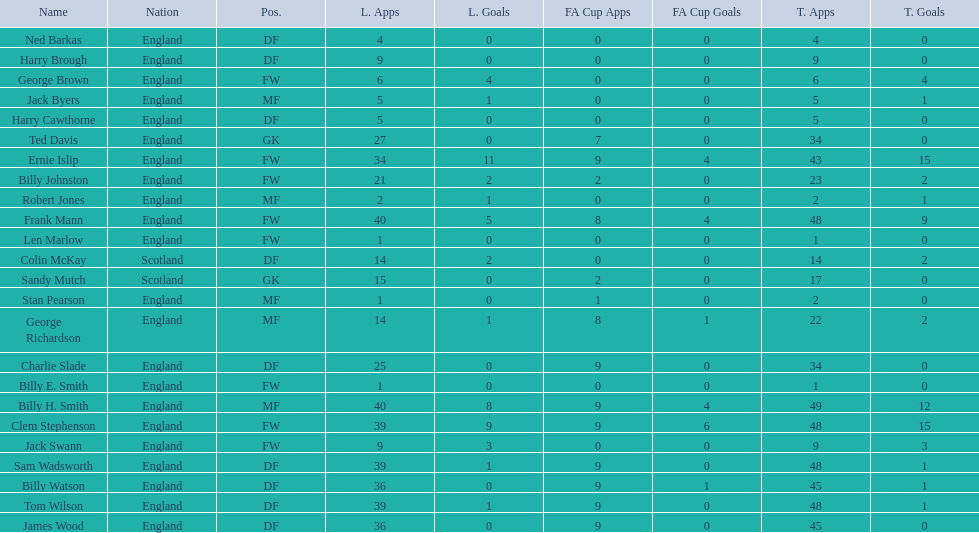Would you mind parsing the complete table? {'header': ['Name', 'Nation', 'Pos.', 'L. Apps', 'L. Goals', 'FA Cup Apps', 'FA Cup Goals', 'T. Apps', 'T. Goals'], 'rows': [['Ned Barkas', 'England', 'DF', '4', '0', '0', '0', '4', '0'], ['Harry Brough', 'England', 'DF', '9', '0', '0', '0', '9', '0'], ['George Brown', 'England', 'FW', '6', '4', '0', '0', '6', '4'], ['Jack Byers', 'England', 'MF', '5', '1', '0', '0', '5', '1'], ['Harry Cawthorne', 'England', 'DF', '5', '0', '0', '0', '5', '0'], ['Ted Davis', 'England', 'GK', '27', '0', '7', '0', '34', '0'], ['Ernie Islip', 'England', 'FW', '34', '11', '9', '4', '43', '15'], ['Billy Johnston', 'England', 'FW', '21', '2', '2', '0', '23', '2'], ['Robert Jones', 'England', 'MF', '2', '1', '0', '0', '2', '1'], ['Frank Mann', 'England', 'FW', '40', '5', '8', '4', '48', '9'], ['Len Marlow', 'England', 'FW', '1', '0', '0', '0', '1', '0'], ['Colin McKay', 'Scotland', 'DF', '14', '2', '0', '0', '14', '2'], ['Sandy Mutch', 'Scotland', 'GK', '15', '0', '2', '0', '17', '0'], ['Stan Pearson', 'England', 'MF', '1', '0', '1', '0', '2', '0'], ['George Richardson', 'England', 'MF', '14', '1', '8', '1', '22', '2'], ['Charlie Slade', 'England', 'DF', '25', '0', '9', '0', '34', '0'], ['Billy E. Smith', 'England', 'FW', '1', '0', '0', '0', '1', '0'], ['Billy H. Smith', 'England', 'MF', '40', '8', '9', '4', '49', '12'], ['Clem Stephenson', 'England', 'FW', '39', '9', '9', '6', '48', '15'], ['Jack Swann', 'England', 'FW', '9', '3', '0', '0', '9', '3'], ['Sam Wadsworth', 'England', 'DF', '39', '1', '9', '0', '48', '1'], ['Billy Watson', 'England', 'DF', '36', '0', '9', '1', '45', '1'], ['Tom Wilson', 'England', 'DF', '39', '1', '9', '0', '48', '1'], ['James Wood', 'England', 'DF', '36', '0', '9', '0', '45', '0']]} What are the number of league apps ted davis has? 27. 